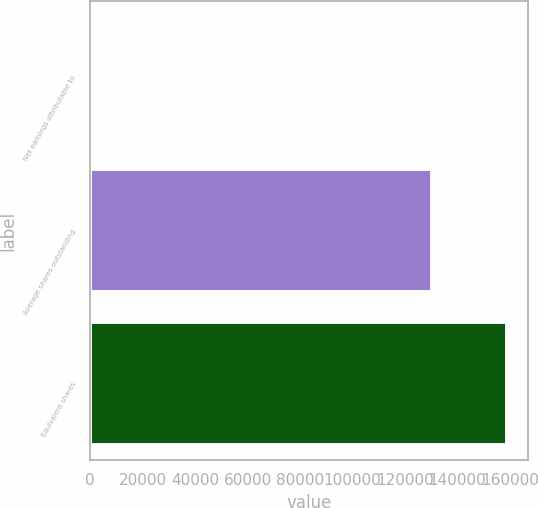Convert chart. <chart><loc_0><loc_0><loc_500><loc_500><bar_chart><fcel>Net earnings attributable to<fcel>Average shares outstanding<fcel>Equivalent shares<nl><fcel>2.2<fcel>130186<fcel>158806<nl></chart> 